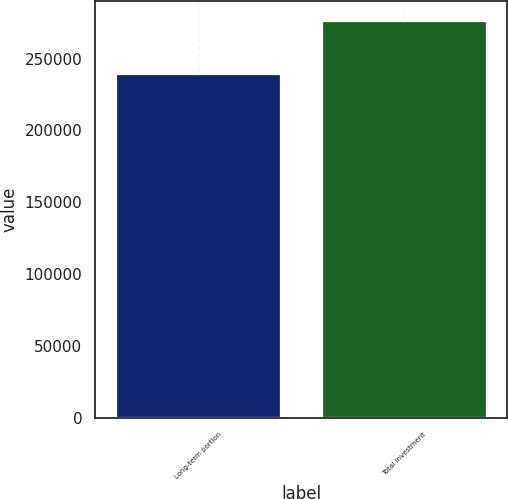Convert chart. <chart><loc_0><loc_0><loc_500><loc_500><bar_chart><fcel>Long-term portion<fcel>Total investment<nl><fcel>239209<fcel>276494<nl></chart> 